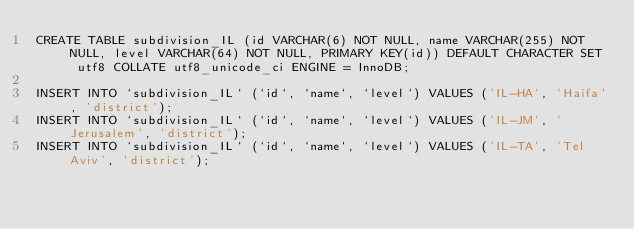<code> <loc_0><loc_0><loc_500><loc_500><_SQL_>CREATE TABLE subdivision_IL (id VARCHAR(6) NOT NULL, name VARCHAR(255) NOT NULL, level VARCHAR(64) NOT NULL, PRIMARY KEY(id)) DEFAULT CHARACTER SET utf8 COLLATE utf8_unicode_ci ENGINE = InnoDB;

INSERT INTO `subdivision_IL` (`id`, `name`, `level`) VALUES ('IL-HA', 'Haifa', 'district');
INSERT INTO `subdivision_IL` (`id`, `name`, `level`) VALUES ('IL-JM', 'Jerusalem', 'district');
INSERT INTO `subdivision_IL` (`id`, `name`, `level`) VALUES ('IL-TA', 'Tel Aviv', 'district');
</code> 